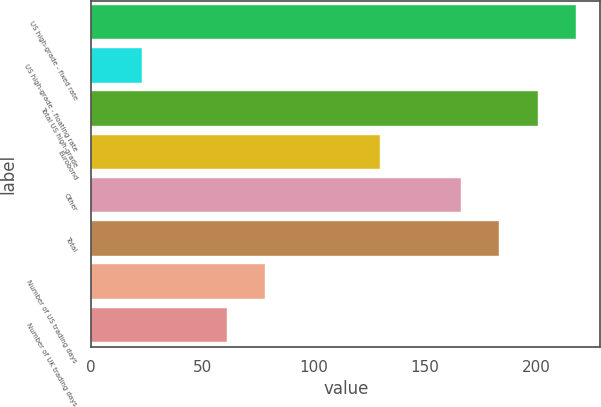Convert chart. <chart><loc_0><loc_0><loc_500><loc_500><bar_chart><fcel>US high-grade - fixed rate<fcel>US high-grade - floating rate<fcel>Total US high-grade<fcel>Eurobond<fcel>Other<fcel>Total<fcel>Number of US trading days<fcel>Number of UK trading days<nl><fcel>217.9<fcel>23<fcel>200.6<fcel>130<fcel>166<fcel>183.3<fcel>78.3<fcel>61<nl></chart> 